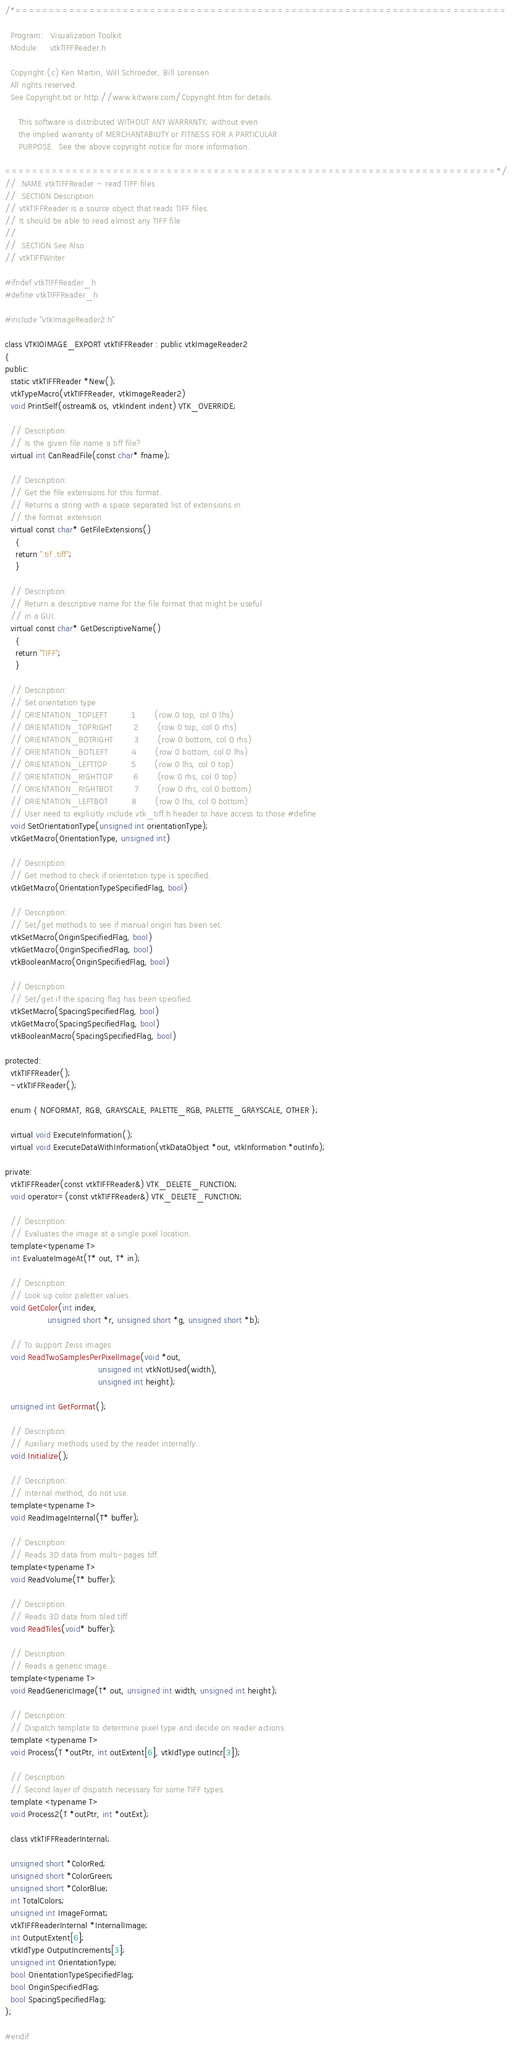Convert code to text. <code><loc_0><loc_0><loc_500><loc_500><_C_>/*=========================================================================

  Program:   Visualization Toolkit
  Module:    vtkTIFFReader.h

  Copyright (c) Ken Martin, Will Schroeder, Bill Lorensen
  All rights reserved.
  See Copyright.txt or http://www.kitware.com/Copyright.htm for details.

     This software is distributed WITHOUT ANY WARRANTY; without even
     the implied warranty of MERCHANTABILITY or FITNESS FOR A PARTICULAR
     PURPOSE.  See the above copyright notice for more information.

=========================================================================*/
// .NAME vtkTIFFReader - read TIFF files
// .SECTION Description
// vtkTIFFReader is a source object that reads TIFF files.
// It should be able to read almost any TIFF file
//
// .SECTION See Also
// vtkTIFFWriter

#ifndef vtkTIFFReader_h
#define vtkTIFFReader_h

#include "vtkImageReader2.h"

class VTKIOIMAGE_EXPORT vtkTIFFReader : public vtkImageReader2
{
public:
  static vtkTIFFReader *New();
  vtkTypeMacro(vtkTIFFReader, vtkImageReader2)
  void PrintSelf(ostream& os, vtkIndent indent) VTK_OVERRIDE;

  // Description:
  // Is the given file name a tiff file?
  virtual int CanReadFile(const char* fname);

  // Description:
  // Get the file extensions for this format.
  // Returns a string with a space separated list of extensions in
  // the format .extension
  virtual const char* GetFileExtensions()
    {
    return ".tif .tiff";
    }

  // Description:
  // Return a descriptive name for the file format that might be useful
  // in a GUI.
  virtual const char* GetDescriptiveName()
    {
    return "TIFF";
    }

  // Description:
  // Set orientation type
  // ORIENTATION_TOPLEFT         1       (row 0 top, col 0 lhs)
  // ORIENTATION_TOPRIGHT        2       (row 0 top, col 0 rhs)
  // ORIENTATION_BOTRIGHT        3       (row 0 bottom, col 0 rhs)
  // ORIENTATION_BOTLEFT         4       (row 0 bottom, col 0 lhs)
  // ORIENTATION_LEFTTOP         5       (row 0 lhs, col 0 top)
  // ORIENTATION_RIGHTTOP        6       (row 0 rhs, col 0 top)
  // ORIENTATION_RIGHTBOT        7       (row 0 rhs, col 0 bottom)
  // ORIENTATION_LEFTBOT         8       (row 0 lhs, col 0 bottom)
  // User need to explicitly include vtk_tiff.h header to have access to those #define
  void SetOrientationType(unsigned int orientationType);
  vtkGetMacro(OrientationType, unsigned int)

  // Description:
  // Get method to check if orientation type is specified.
  vtkGetMacro(OrientationTypeSpecifiedFlag, bool)

  // Description:
  // Set/get methods to see if manual origin has been set.
  vtkSetMacro(OriginSpecifiedFlag, bool)
  vtkGetMacro(OriginSpecifiedFlag, bool)
  vtkBooleanMacro(OriginSpecifiedFlag, bool)

  // Description:
  // Set/get if the spacing flag has been specified.
  vtkSetMacro(SpacingSpecifiedFlag, bool)
  vtkGetMacro(SpacingSpecifiedFlag, bool)
  vtkBooleanMacro(SpacingSpecifiedFlag, bool)

protected:
  vtkTIFFReader();
  ~vtkTIFFReader();

  enum { NOFORMAT, RGB, GRAYSCALE, PALETTE_RGB, PALETTE_GRAYSCALE, OTHER };

  virtual void ExecuteInformation();
  virtual void ExecuteDataWithInformation(vtkDataObject *out, vtkInformation *outInfo);

private:
  vtkTIFFReader(const vtkTIFFReader&) VTK_DELETE_FUNCTION;
  void operator=(const vtkTIFFReader&) VTK_DELETE_FUNCTION;

  // Description:
  // Evaluates the image at a single pixel location.
  template<typename T>
  int EvaluateImageAt(T* out, T* in);

  // Description:
  // Look up color paletter values.
  void GetColor(int index,
                unsigned short *r, unsigned short *g, unsigned short *b);

  // To support Zeiss images
  void ReadTwoSamplesPerPixelImage(void *out,
                                   unsigned int vtkNotUsed(width),
                                   unsigned int height);

  unsigned int GetFormat();

  // Description:
  // Auxiliary methods used by the reader internally.
  void Initialize();

  // Description:
  // Internal method, do not use.
  template<typename T>
  void ReadImageInternal(T* buffer);

  // Description:
  // Reads 3D data from multi-pages tiff.
  template<typename T>
  void ReadVolume(T* buffer);

  // Description:
  // Reads 3D data from tiled tiff
  void ReadTiles(void* buffer);

  // Description:
  // Reads a generic image.
  template<typename T>
  void ReadGenericImage(T* out, unsigned int width, unsigned int height);

  // Description:
  // Dispatch template to determine pixel type and decide on reader actions.
  template <typename T>
  void Process(T *outPtr, int outExtent[6], vtkIdType outIncr[3]);

  // Description:
  // Second layer of dispatch necessary for some TIFF types.
  template <typename T>
  void Process2(T *outPtr, int *outExt);

  class vtkTIFFReaderInternal;

  unsigned short *ColorRed;
  unsigned short *ColorGreen;
  unsigned short *ColorBlue;
  int TotalColors;
  unsigned int ImageFormat;
  vtkTIFFReaderInternal *InternalImage;
  int OutputExtent[6];
  vtkIdType OutputIncrements[3];
  unsigned int OrientationType;
  bool OrientationTypeSpecifiedFlag;
  bool OriginSpecifiedFlag;
  bool SpacingSpecifiedFlag;
};

#endif
</code> 